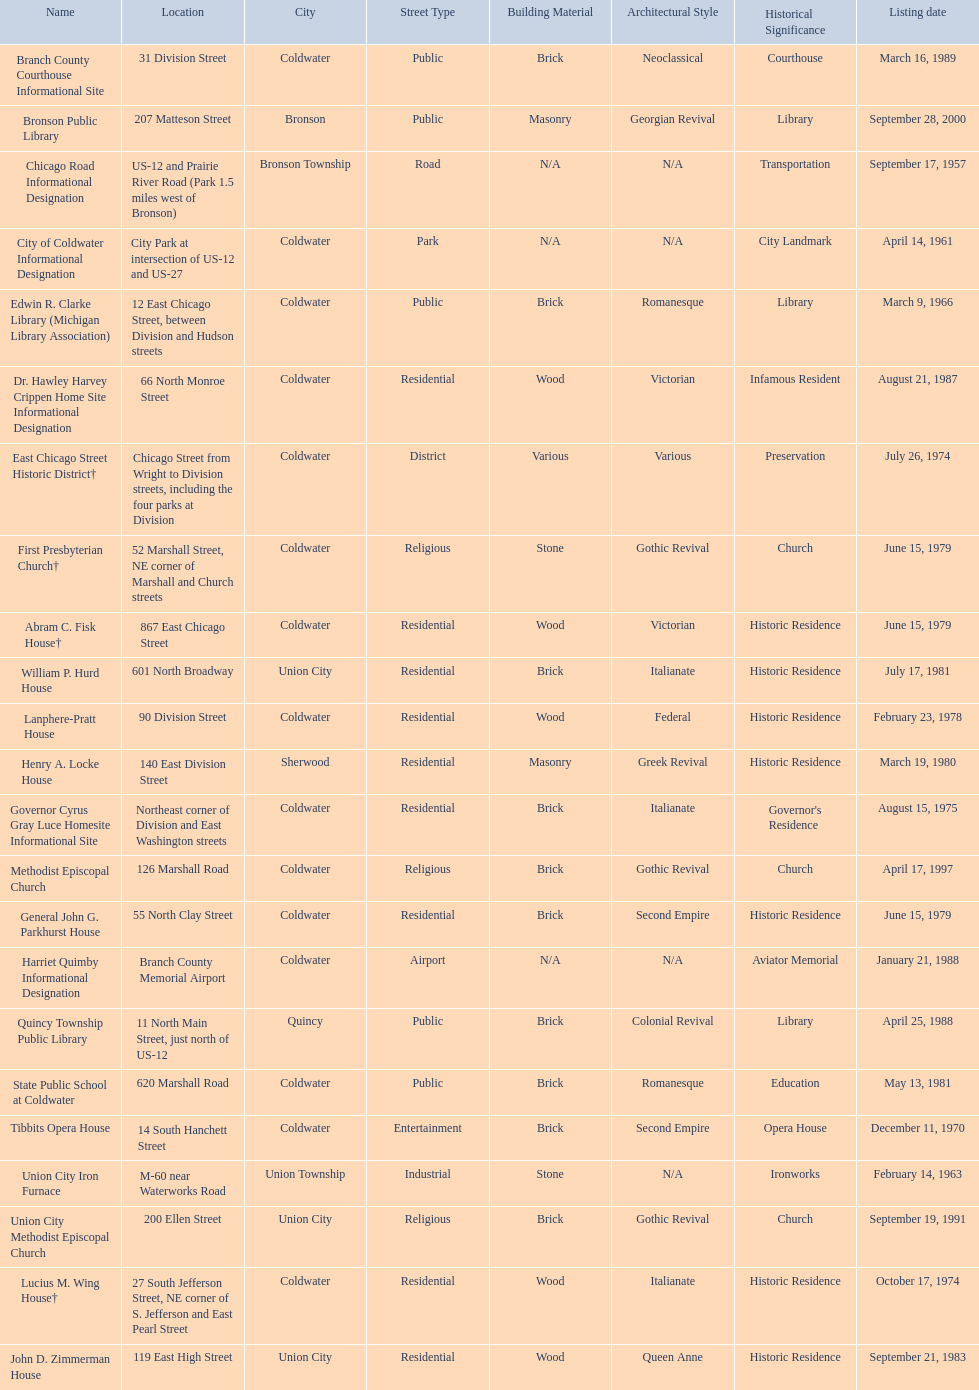What are all of the locations considered historical sites in branch county, michigan? Branch County Courthouse Informational Site, Bronson Public Library, Chicago Road Informational Designation, City of Coldwater Informational Designation, Edwin R. Clarke Library (Michigan Library Association), Dr. Hawley Harvey Crippen Home Site Informational Designation, East Chicago Street Historic District†, First Presbyterian Church†, Abram C. Fisk House†, William P. Hurd House, Lanphere-Pratt House, Henry A. Locke House, Governor Cyrus Gray Luce Homesite Informational Site, Methodist Episcopal Church, General John G. Parkhurst House, Harriet Quimby Informational Designation, Quincy Township Public Library, State Public School at Coldwater, Tibbits Opera House, Union City Iron Furnace, Union City Methodist Episcopal Church, Lucius M. Wing House†, John D. Zimmerman House. Of those sites, which one was the first to be listed as historical? Chicago Road Informational Designation. 